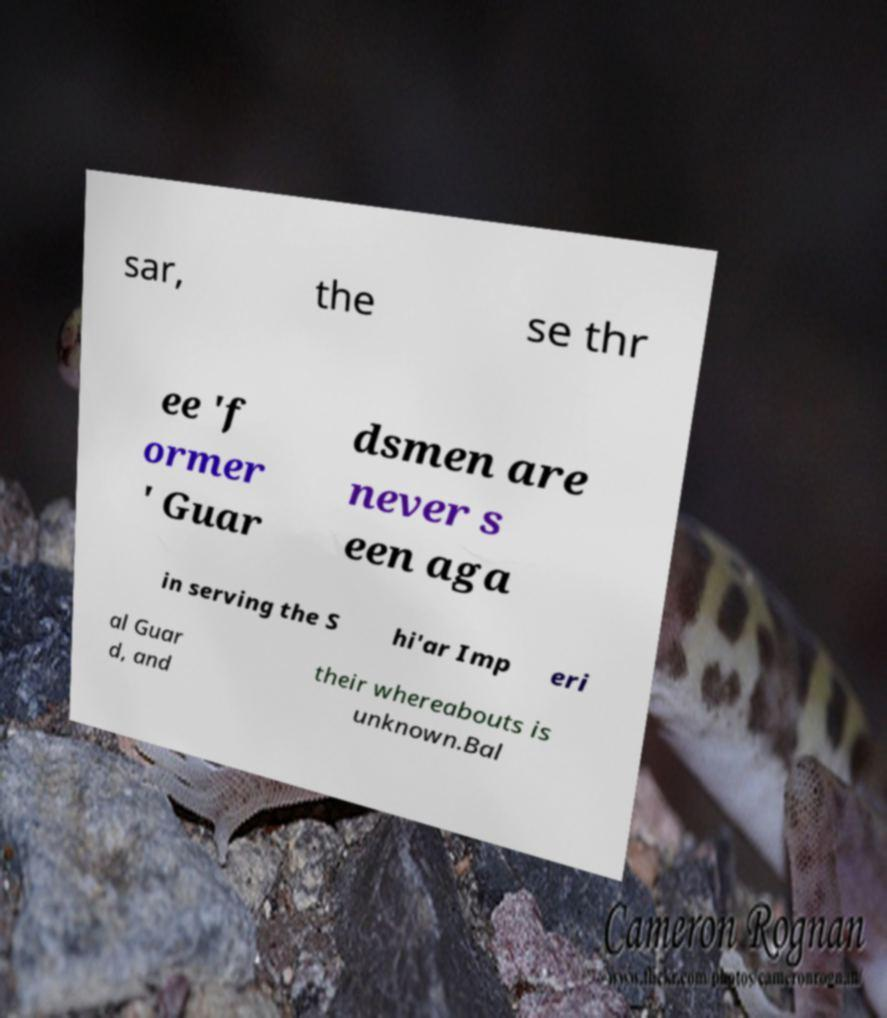Could you extract and type out the text from this image? sar, the se thr ee 'f ormer ' Guar dsmen are never s een aga in serving the S hi'ar Imp eri al Guar d, and their whereabouts is unknown.Bal 